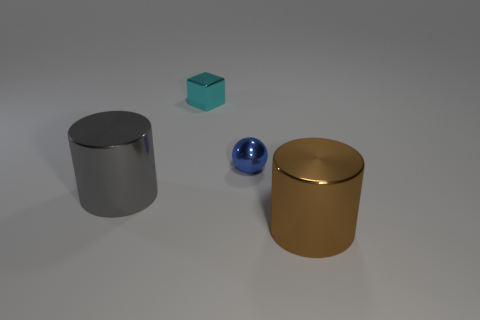Subtract all brown cylinders. How many cylinders are left? 1 Add 4 small cyan things. How many objects exist? 8 Add 3 gray cylinders. How many gray cylinders are left? 4 Add 3 small cyan metallic things. How many small cyan metallic things exist? 4 Subtract 1 blue balls. How many objects are left? 3 Subtract all balls. How many objects are left? 3 Subtract 2 cylinders. How many cylinders are left? 0 Subtract all gray cylinders. Subtract all purple blocks. How many cylinders are left? 1 Subtract all green cubes. How many gray cylinders are left? 1 Subtract all yellow balls. Subtract all blue shiny things. How many objects are left? 3 